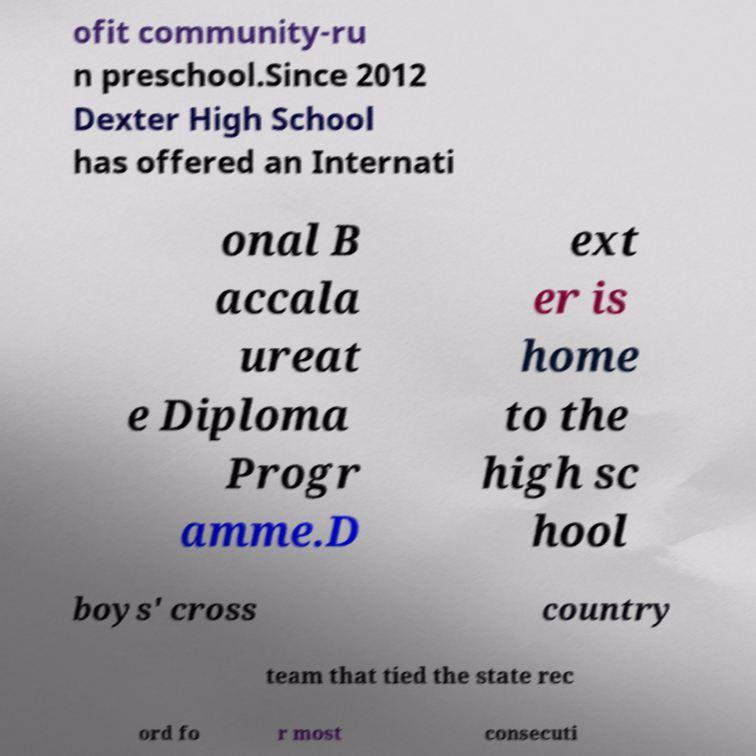Please identify and transcribe the text found in this image. ofit community-ru n preschool.Since 2012 Dexter High School has offered an Internati onal B accala ureat e Diploma Progr amme.D ext er is home to the high sc hool boys' cross country team that tied the state rec ord fo r most consecuti 